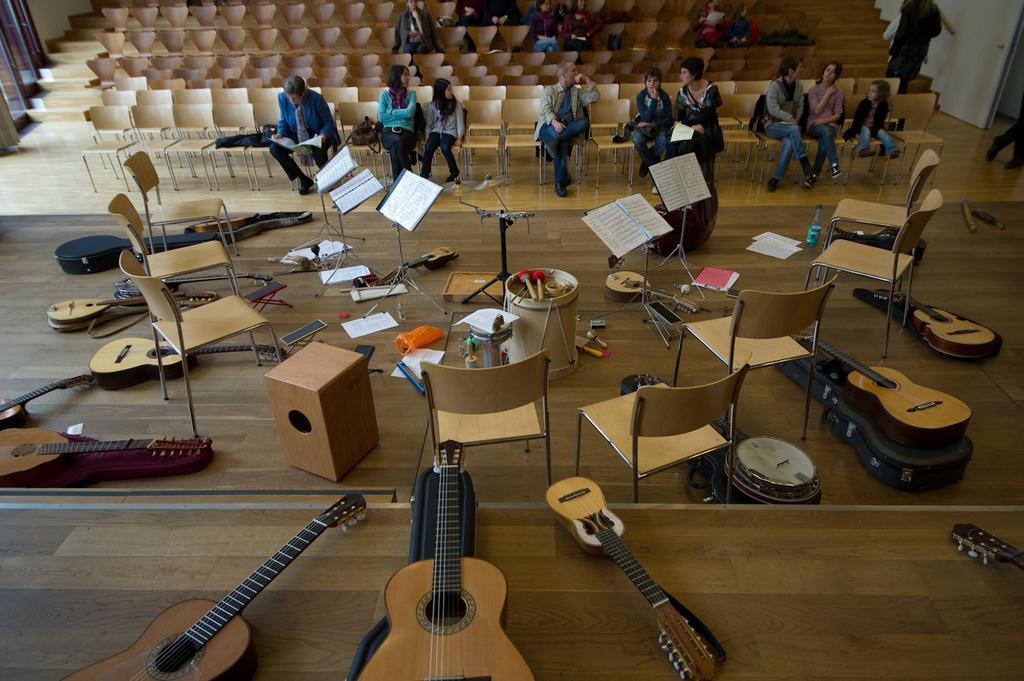Describe this image in one or two sentences. In this picture we can able to see guitars, chairs, musical drum with sticks, papers, book stand, bottle, plastic cover and cables. Front there are chairs, on this chairs persons are sitting and there are bags on this chair. 